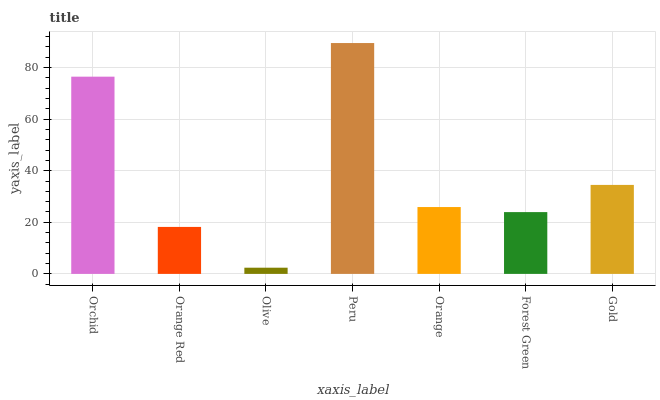Is Orange Red the minimum?
Answer yes or no. No. Is Orange Red the maximum?
Answer yes or no. No. Is Orchid greater than Orange Red?
Answer yes or no. Yes. Is Orange Red less than Orchid?
Answer yes or no. Yes. Is Orange Red greater than Orchid?
Answer yes or no. No. Is Orchid less than Orange Red?
Answer yes or no. No. Is Orange the high median?
Answer yes or no. Yes. Is Orange the low median?
Answer yes or no. Yes. Is Forest Green the high median?
Answer yes or no. No. Is Peru the low median?
Answer yes or no. No. 